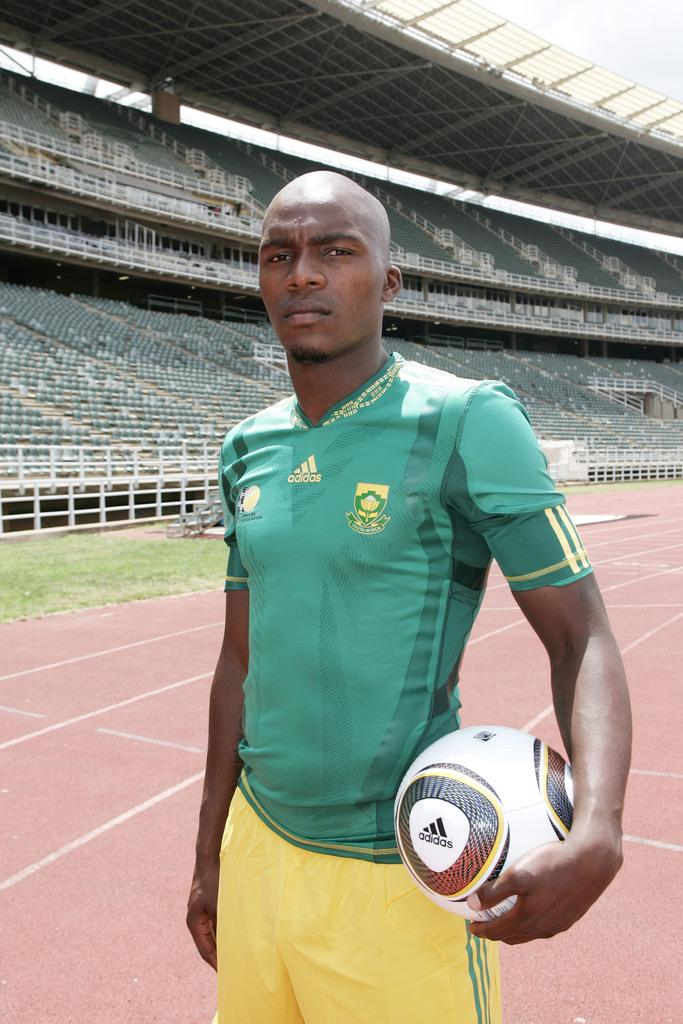Who is present in the image? There is a man in the image. What is the man doing in the image? The man is posing for the camera. What object is the man holding in the image? The man is holding a football. Where was the image taken? The location is a stadium. What type of wine is being served to the man in the image? There is no wine present in the image; the man is holding a football. Can you describe the worm that is crawling on the man's shoulder in the image? There is no worm present in the image; the man is posing for the camera and holding a football. 